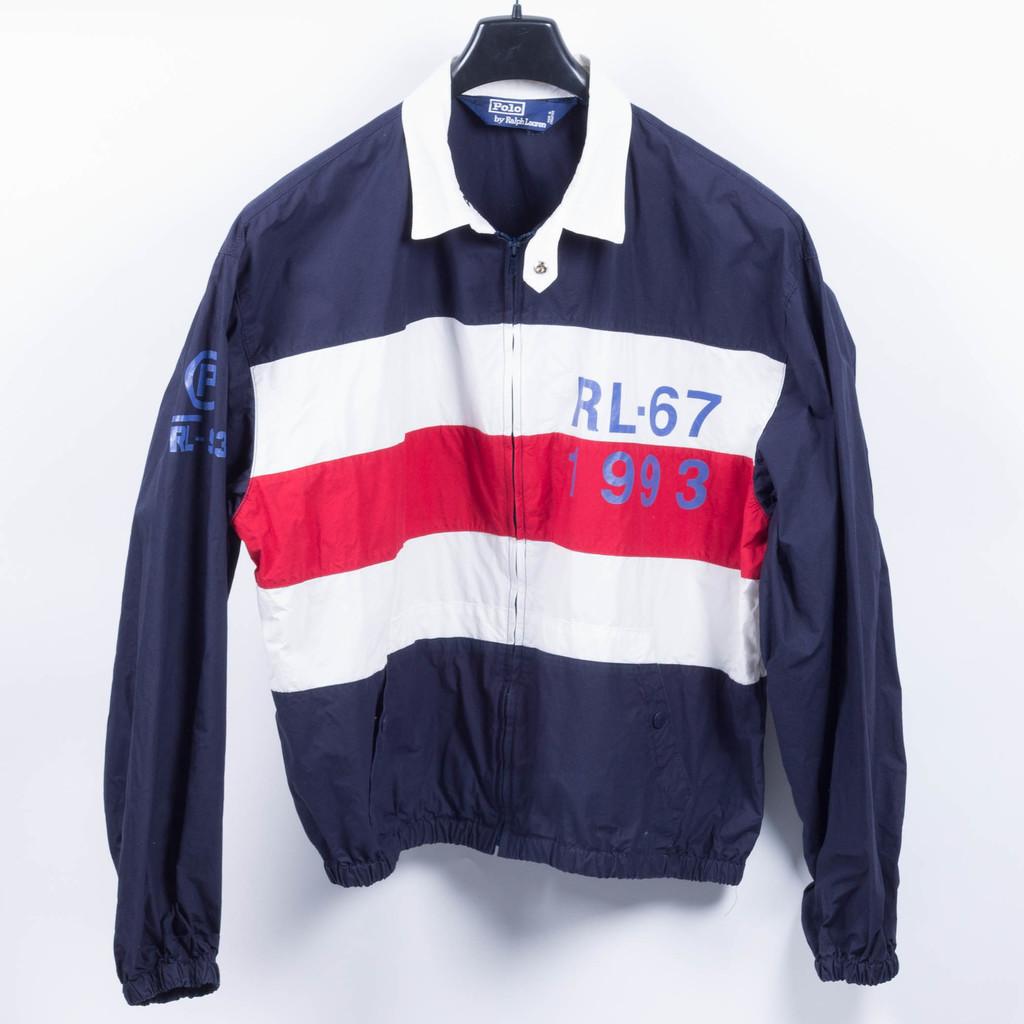What date is on the red stripe on this jacket?
Your answer should be compact. 1993. What color is the collar of this shirt?
Give a very brief answer. Answering does not require reading text in the image. 